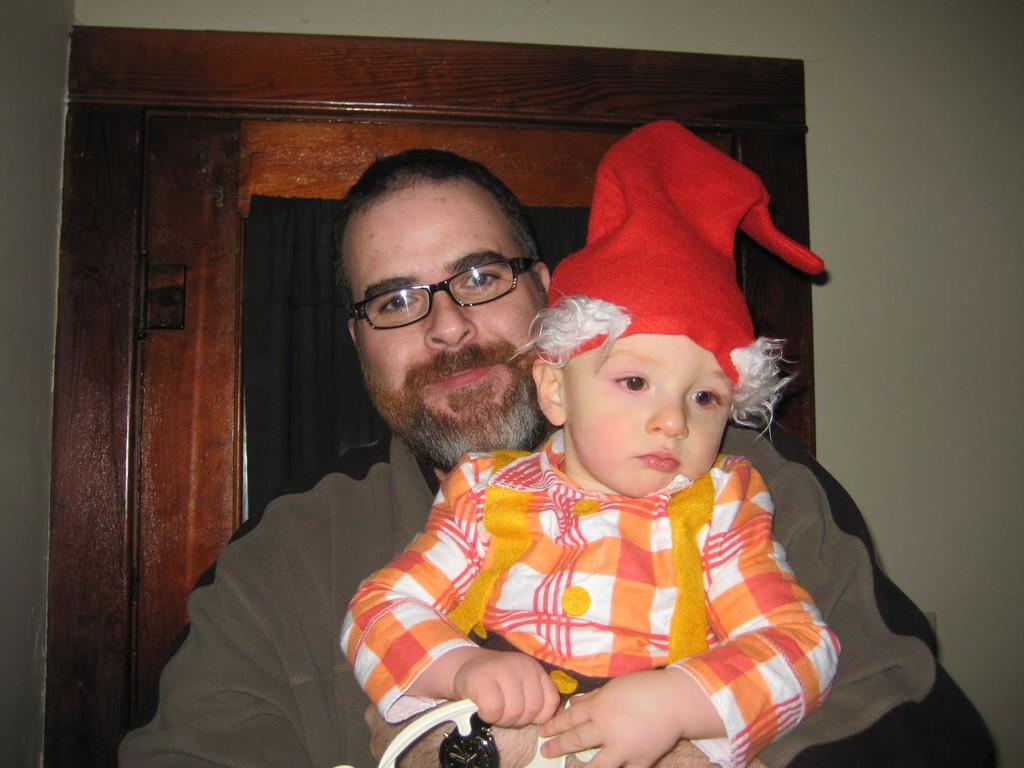What is the person in the image wearing? The person is wearing spectacles in the image. What is the person doing with the baby? The person is holding a baby in the image. What can be seen in the background of the image? There is a wall and a door in the background of the image. Where is the desk located in the image? There is no desk present in the image. What type of dust can be seen on the baby's face in the image? There is no dust visible on the baby's face in the image, and the baby is not present in the image. 